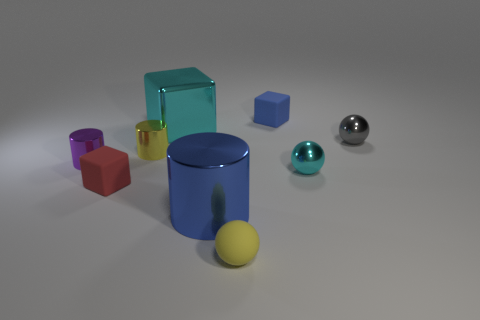Subtract all tiny red blocks. How many blocks are left? 2 Add 1 large red metallic spheres. How many objects exist? 10 Subtract 1 cubes. How many cubes are left? 2 Subtract all blocks. How many objects are left? 6 Add 7 big cyan objects. How many big cyan objects exist? 8 Subtract 0 red cylinders. How many objects are left? 9 Subtract all brown balls. Subtract all brown blocks. How many balls are left? 3 Subtract all small purple things. Subtract all red rubber cubes. How many objects are left? 7 Add 5 matte blocks. How many matte blocks are left? 7 